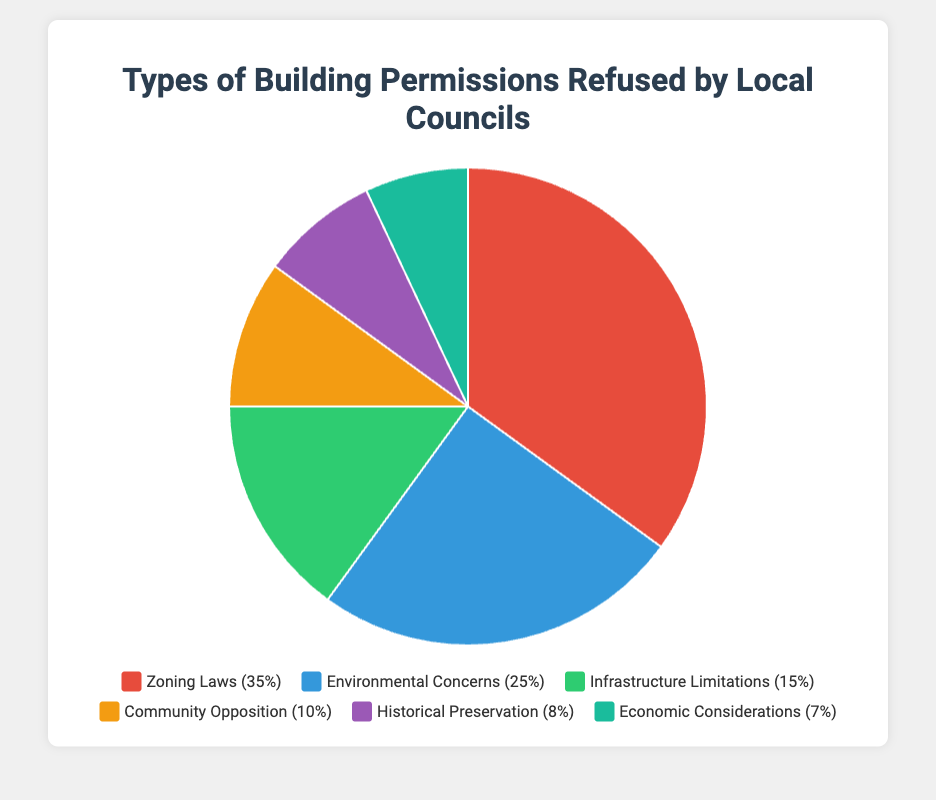Which type of refusals has the highest percentage? Among all the segments in the pie chart, the one labeled "Zoning Laws" occupies the largest portion with a percentage of 35%.
Answer: Zoning Laws What are the top two reasons for building permission refusals based on the percentages? The two largest segments in the pie chart are "Zoning Laws" with 35% and "Environmental Concerns" with 25%.
Answer: Zoning Laws and Environmental Concerns Which refusal reason accounts for 8% of the total? The segment labeled "Historical Preservation" is indicated as taking up 8% of the pie chart.
Answer: Historical Preservation What is the combined percentage for "Community Opposition" and "Economic Considerations"? Summing the percentages for "Community Opposition" (10%) and "Economic Considerations" (7%) results in a total of 17%.
Answer: 17% How does the percentage of "Infrastructure Limitations" compare to "Community Opposition"? The pie chart shows "Infrastructure Limitations" at 15% and "Community Opposition" at 10%, indicating that "Infrastructure Limitations" is 5 percentage points higher.
Answer: Infrastructure Limitations is 5% higher What color is used to represent "Environmental Concerns"? The segment labeled "Environmental Concerns" is colored blue in the pie chart.
Answer: Blue Which segment has a lower percentage, "Historical Preservation" or "Infrastructure Limitations"? The pie chart indicates that "Historical Preservation" is 8% and "Infrastructure Limitations" is 15%; therefore, "Historical Preservation" has a lower percentage.
Answer: Historical Preservation What is the average percentage of "Environmental Concerns", "Community Opposition", and "Economic Considerations"? The percentages for these segments are 25%, 10%, and 7%, respectively. Summing these values gives 42%, and dividing by 3 yields an average of 14%.
Answer: 14% What are the reasons associated with "Community Opposition"? According to the legend, "Community Opposition" includes local resident protests, petitions against development, and community board rejections.
Answer: Local resident protests, petitions against development, and community board rejections 